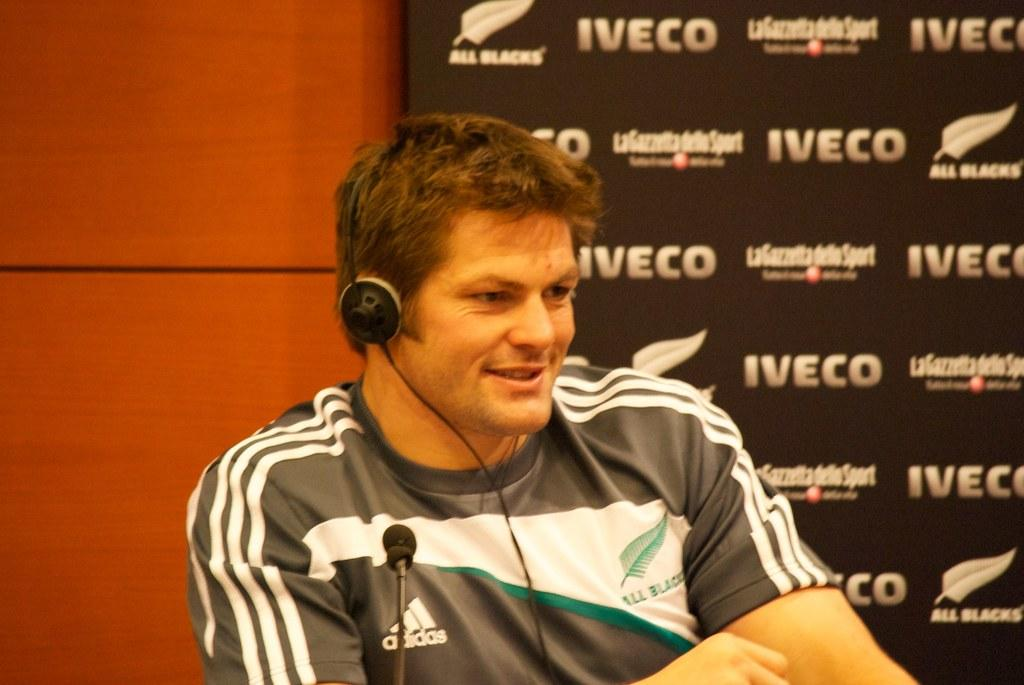Provide a one-sentence caption for the provided image. An adult man wearing an Adidas shirt talks into a microphone. 